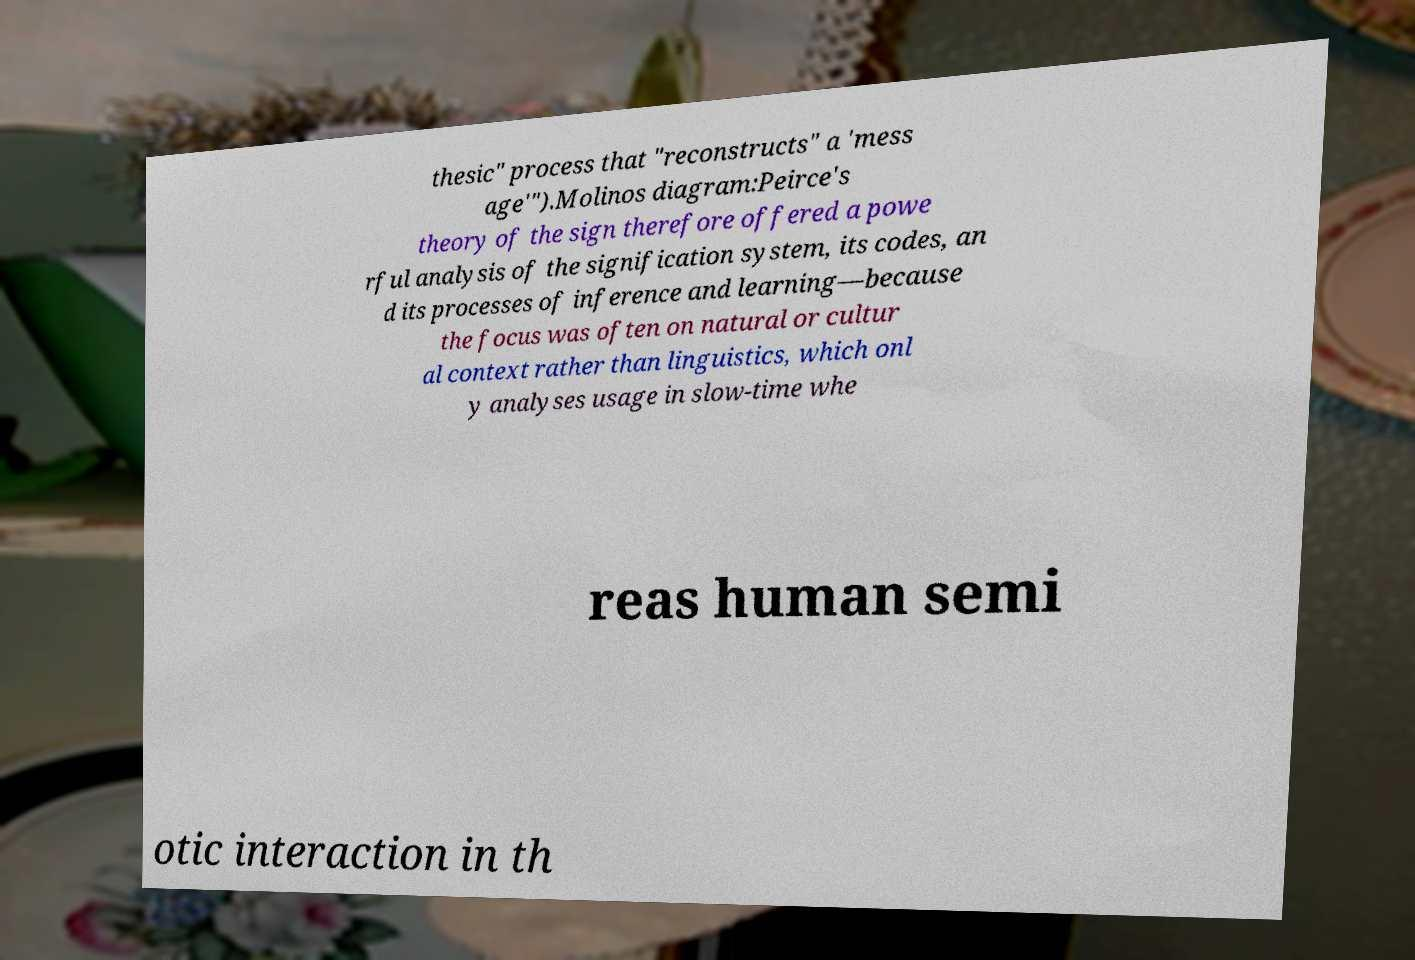Please identify and transcribe the text found in this image. thesic" process that "reconstructs" a 'mess age'").Molinos diagram:Peirce's theory of the sign therefore offered a powe rful analysis of the signification system, its codes, an d its processes of inference and learning—because the focus was often on natural or cultur al context rather than linguistics, which onl y analyses usage in slow-time whe reas human semi otic interaction in th 